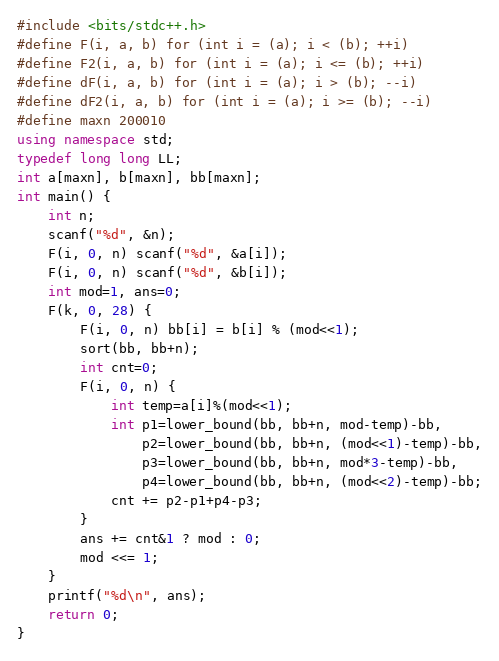<code> <loc_0><loc_0><loc_500><loc_500><_C++_>#include <bits/stdc++.h>
#define F(i, a, b) for (int i = (a); i < (b); ++i)
#define F2(i, a, b) for (int i = (a); i <= (b); ++i)
#define dF(i, a, b) for (int i = (a); i > (b); --i)
#define dF2(i, a, b) for (int i = (a); i >= (b); --i)
#define maxn 200010
using namespace std;
typedef long long LL;
int a[maxn], b[maxn], bb[maxn];
int main() {
    int n;
    scanf("%d", &n);
    F(i, 0, n) scanf("%d", &a[i]);
    F(i, 0, n) scanf("%d", &b[i]);
    int mod=1, ans=0;
    F(k, 0, 28) {
        F(i, 0, n) bb[i] = b[i] % (mod<<1);
        sort(bb, bb+n);
        int cnt=0;
        F(i, 0, n) {
            int temp=a[i]%(mod<<1);
            int p1=lower_bound(bb, bb+n, mod-temp)-bb,
                p2=lower_bound(bb, bb+n, (mod<<1)-temp)-bb,
                p3=lower_bound(bb, bb+n, mod*3-temp)-bb,
                p4=lower_bound(bb, bb+n, (mod<<2)-temp)-bb;
            cnt += p2-p1+p4-p3;
        }
        ans += cnt&1 ? mod : 0;
        mod <<= 1;
    }
    printf("%d\n", ans);
    return 0;
}
</code> 